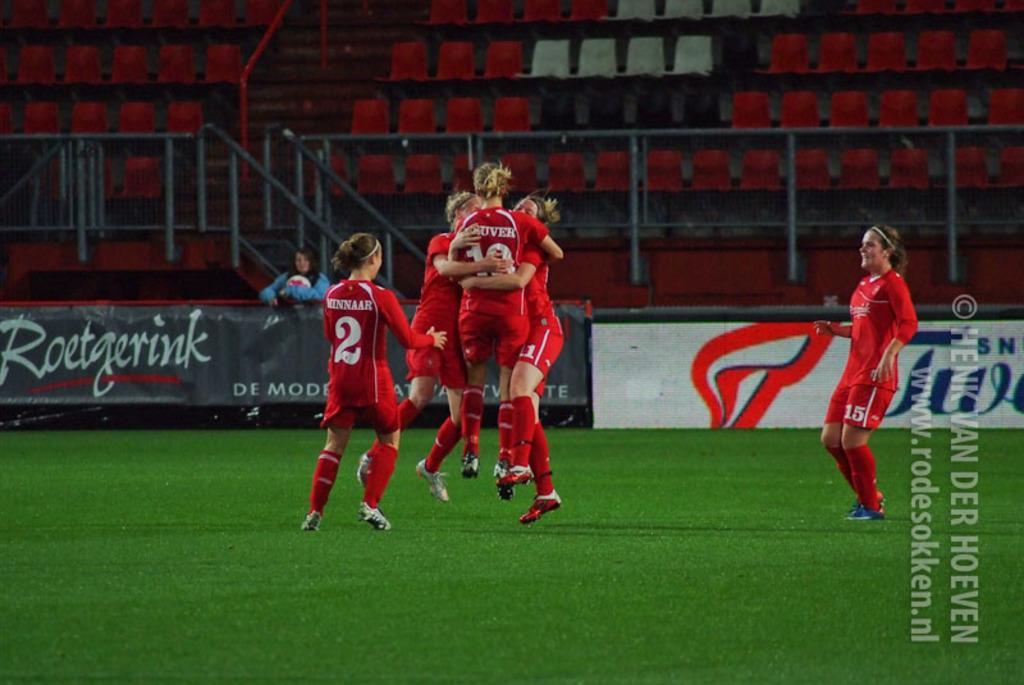Please provide a concise description of this image. In the center of the image we can see a few people are in red color costumes. On the right side of the image, there is a watermark. In the background, we can see chairs, fences, banners, grass and two persons. 